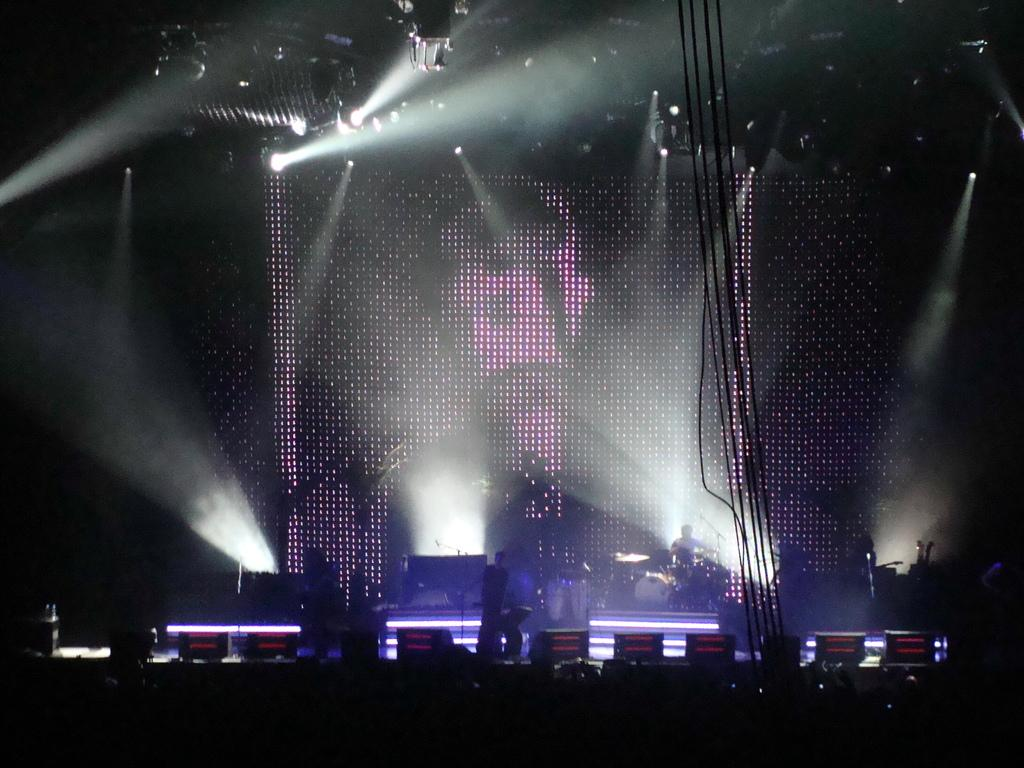What are the people in the image doing? Some people are seated, while others are standing on a dais, and some are performing in the image. Can you describe the people on the dais? The people on the dais are standing. What can be seen in the image that provides illumination? There are lights visible in the image. What instrument is being played by one of the performers? A man is playing drums in the image. How many people are in the crowd watching the performance in the image? There is no crowd visible in the image; it only shows people seated, standing on a dais, and performing. What type of owl can be seen perched on the drummer's shoulder in the image? There is no owl present in the image; only people and instruments are visible. 